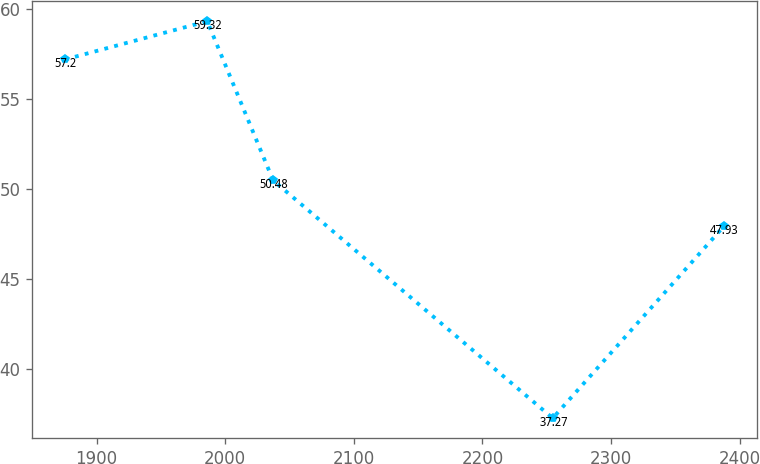Convert chart. <chart><loc_0><loc_0><loc_500><loc_500><line_chart><ecel><fcel>Unnamed: 1<nl><fcel>1875.59<fcel>57.2<nl><fcel>1986.08<fcel>59.32<nl><fcel>2037.29<fcel>50.48<nl><fcel>2254.67<fcel>37.27<nl><fcel>2387.69<fcel>47.93<nl></chart> 